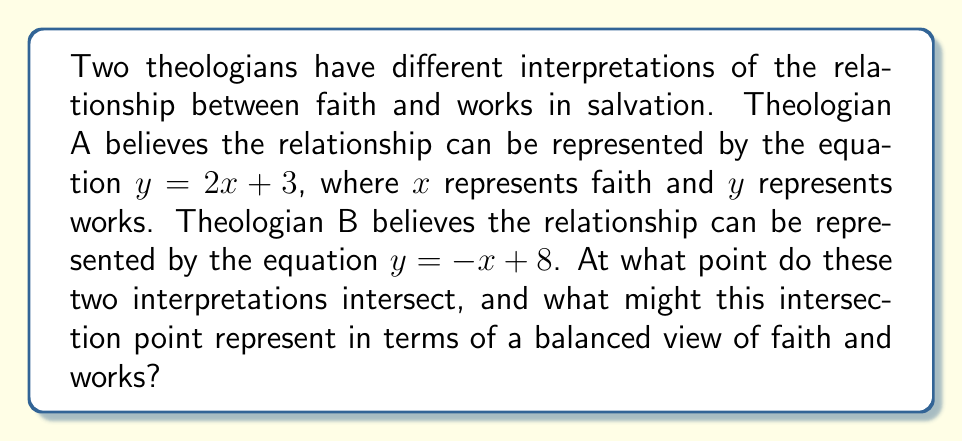Could you help me with this problem? To find the intersection point of these two theological interpretations, we need to solve the system of linear equations:

$$\begin{cases}
y = 2x + 3 \\
y = -x + 8
\end{cases}$$

We can solve this system using the substitution method:

1) Since both equations are equal to $y$, we can set them equal to each other:

   $2x + 3 = -x + 8$

2) Add $x$ to both sides:

   $3x + 3 = 8$

3) Subtract 3 from both sides:

   $3x = 5$

4) Divide both sides by 3:

   $x = \frac{5}{3}$

5) Now that we know $x$, we can substitute this value into either of the original equations to find $y$. Let's use the first equation:

   $y = 2(\frac{5}{3}) + 3$
   $y = \frac{10}{3} + 3$
   $y = \frac{10}{3} + \frac{9}{3}$
   $y = \frac{19}{3}$

Therefore, the point of intersection is $(\frac{5}{3}, \frac{19}{3})$.

In the context of the theological debate, this intersection point could represent a balanced view where faith ($x = \frac{5}{3}$) and works ($y = \frac{19}{3}$) are both present and in harmony. This aligns with the persona's appreciation for accurate representation in Christian dialogue, as it acknowledges the importance of both faith and works in a believer's life.
Answer: The point of intersection is $(\frac{5}{3}, \frac{19}{3})$. 